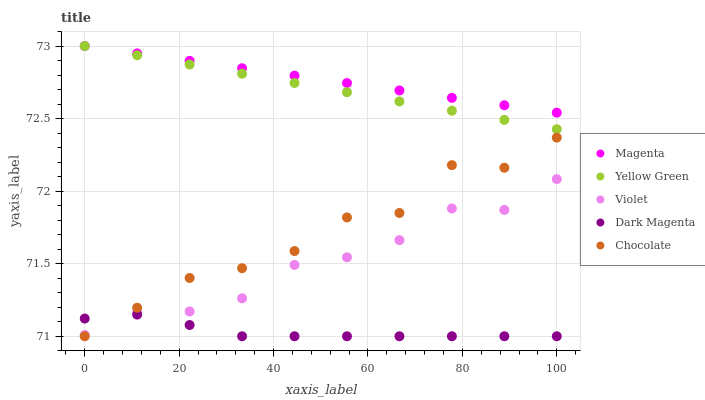Does Dark Magenta have the minimum area under the curve?
Answer yes or no. Yes. Does Magenta have the maximum area under the curve?
Answer yes or no. Yes. Does Chocolate have the minimum area under the curve?
Answer yes or no. No. Does Chocolate have the maximum area under the curve?
Answer yes or no. No. Is Magenta the smoothest?
Answer yes or no. Yes. Is Chocolate the roughest?
Answer yes or no. Yes. Is Yellow Green the smoothest?
Answer yes or no. No. Is Yellow Green the roughest?
Answer yes or no. No. Does Chocolate have the lowest value?
Answer yes or no. Yes. Does Yellow Green have the lowest value?
Answer yes or no. No. Does Yellow Green have the highest value?
Answer yes or no. Yes. Does Chocolate have the highest value?
Answer yes or no. No. Is Dark Magenta less than Magenta?
Answer yes or no. Yes. Is Yellow Green greater than Chocolate?
Answer yes or no. Yes. Does Yellow Green intersect Magenta?
Answer yes or no. Yes. Is Yellow Green less than Magenta?
Answer yes or no. No. Is Yellow Green greater than Magenta?
Answer yes or no. No. Does Dark Magenta intersect Magenta?
Answer yes or no. No. 